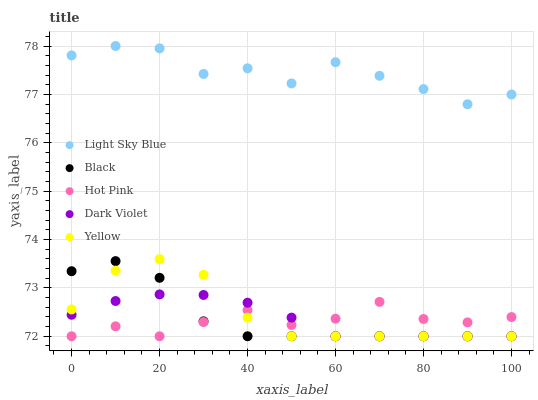Does Hot Pink have the minimum area under the curve?
Answer yes or no. Yes. Does Light Sky Blue have the maximum area under the curve?
Answer yes or no. Yes. Does Black have the minimum area under the curve?
Answer yes or no. No. Does Black have the maximum area under the curve?
Answer yes or no. No. Is Dark Violet the smoothest?
Answer yes or no. Yes. Is Light Sky Blue the roughest?
Answer yes or no. Yes. Is Black the smoothest?
Answer yes or no. No. Is Black the roughest?
Answer yes or no. No. Does Black have the lowest value?
Answer yes or no. Yes. Does Light Sky Blue have the highest value?
Answer yes or no. Yes. Does Black have the highest value?
Answer yes or no. No. Is Yellow less than Light Sky Blue?
Answer yes or no. Yes. Is Light Sky Blue greater than Hot Pink?
Answer yes or no. Yes. Does Dark Violet intersect Yellow?
Answer yes or no. Yes. Is Dark Violet less than Yellow?
Answer yes or no. No. Is Dark Violet greater than Yellow?
Answer yes or no. No. Does Yellow intersect Light Sky Blue?
Answer yes or no. No. 